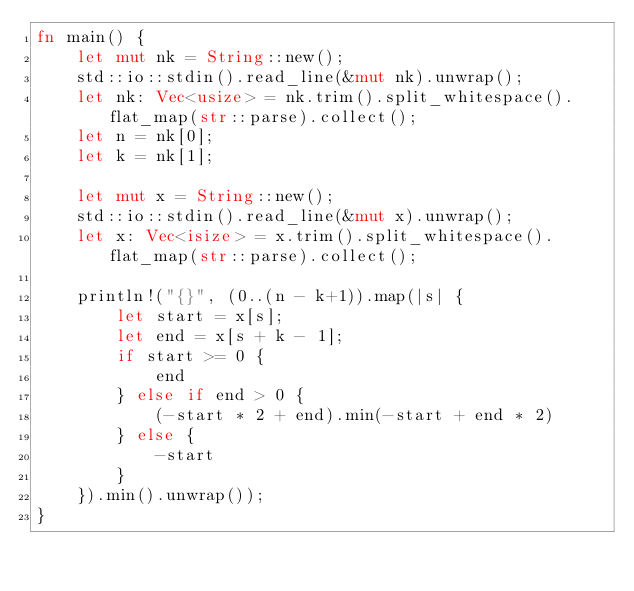<code> <loc_0><loc_0><loc_500><loc_500><_Rust_>fn main() {
    let mut nk = String::new();
    std::io::stdin().read_line(&mut nk).unwrap();
    let nk: Vec<usize> = nk.trim().split_whitespace().flat_map(str::parse).collect();
    let n = nk[0];
    let k = nk[1];

    let mut x = String::new();
    std::io::stdin().read_line(&mut x).unwrap();
    let x: Vec<isize> = x.trim().split_whitespace().flat_map(str::parse).collect();

    println!("{}", (0..(n - k+1)).map(|s| {
        let start = x[s];
        let end = x[s + k - 1];
        if start >= 0 {
            end
        } else if end > 0 {
            (-start * 2 + end).min(-start + end * 2)
        } else {
            -start
        }
    }).min().unwrap());
}
</code> 